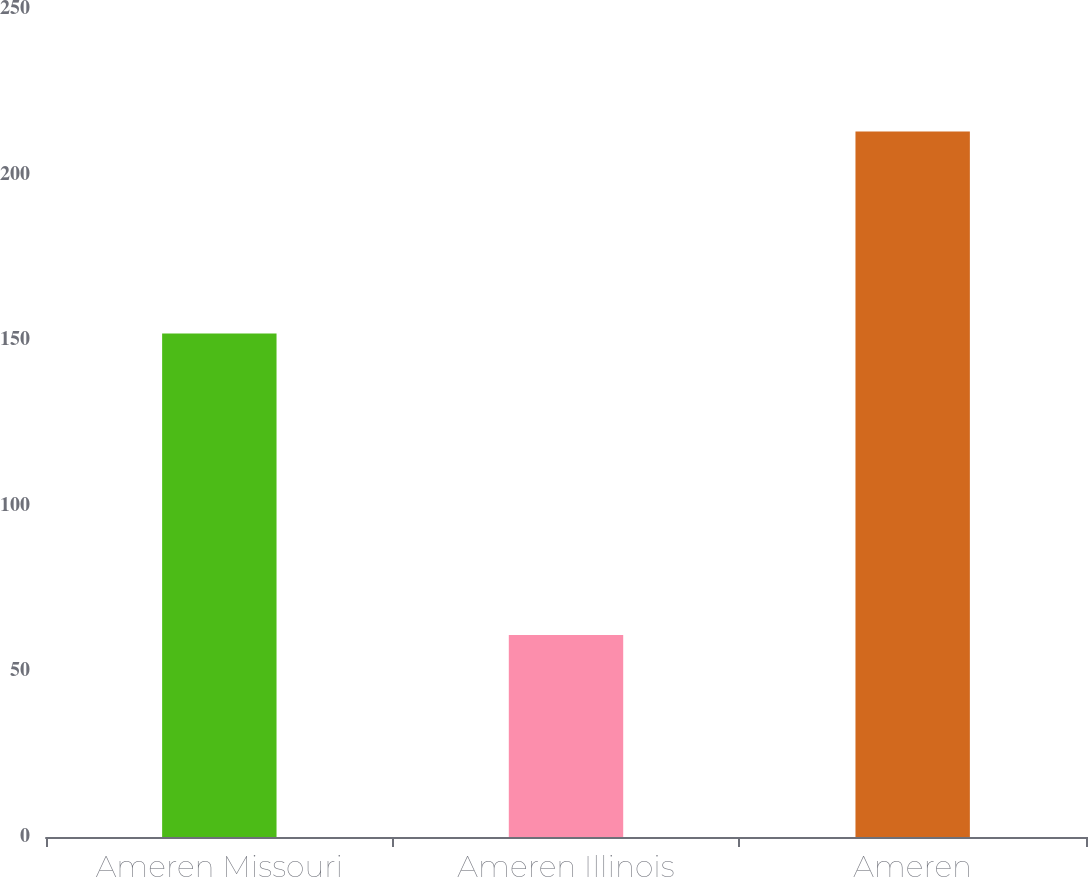Convert chart to OTSL. <chart><loc_0><loc_0><loc_500><loc_500><bar_chart><fcel>Ameren Missouri<fcel>Ameren Illinois<fcel>Ameren<nl><fcel>152<fcel>61<fcel>213<nl></chart> 